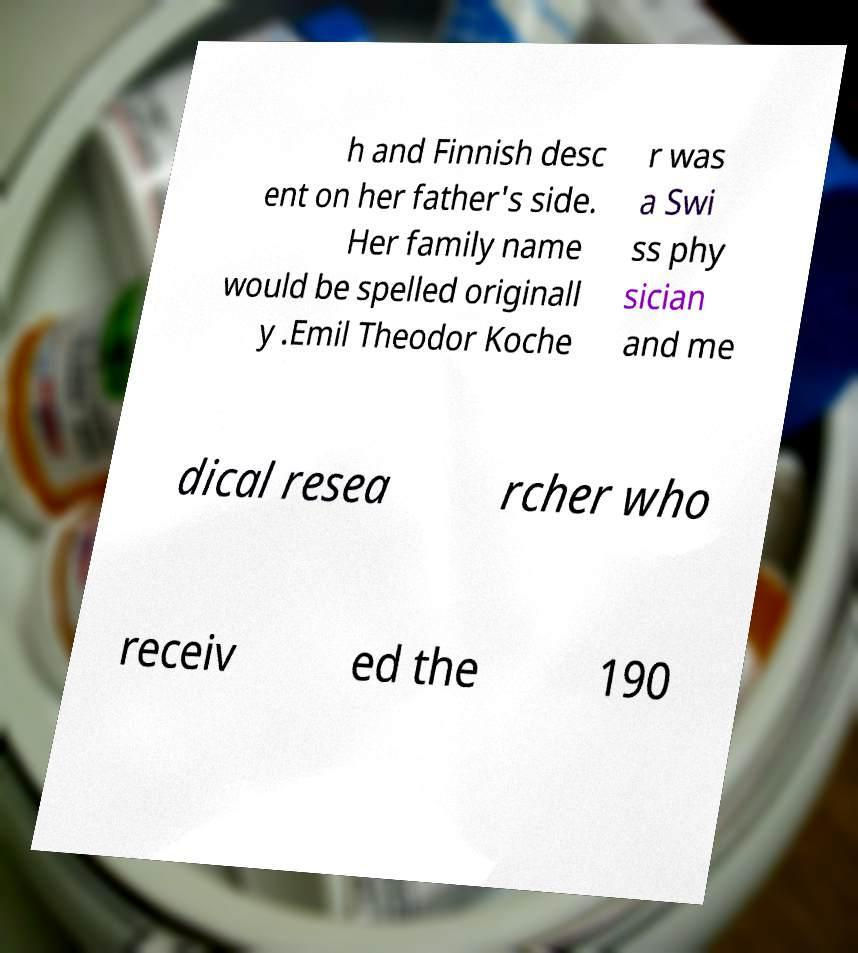What messages or text are displayed in this image? I need them in a readable, typed format. h and Finnish desc ent on her father's side. Her family name would be spelled originall y .Emil Theodor Koche r was a Swi ss phy sician and me dical resea rcher who receiv ed the 190 